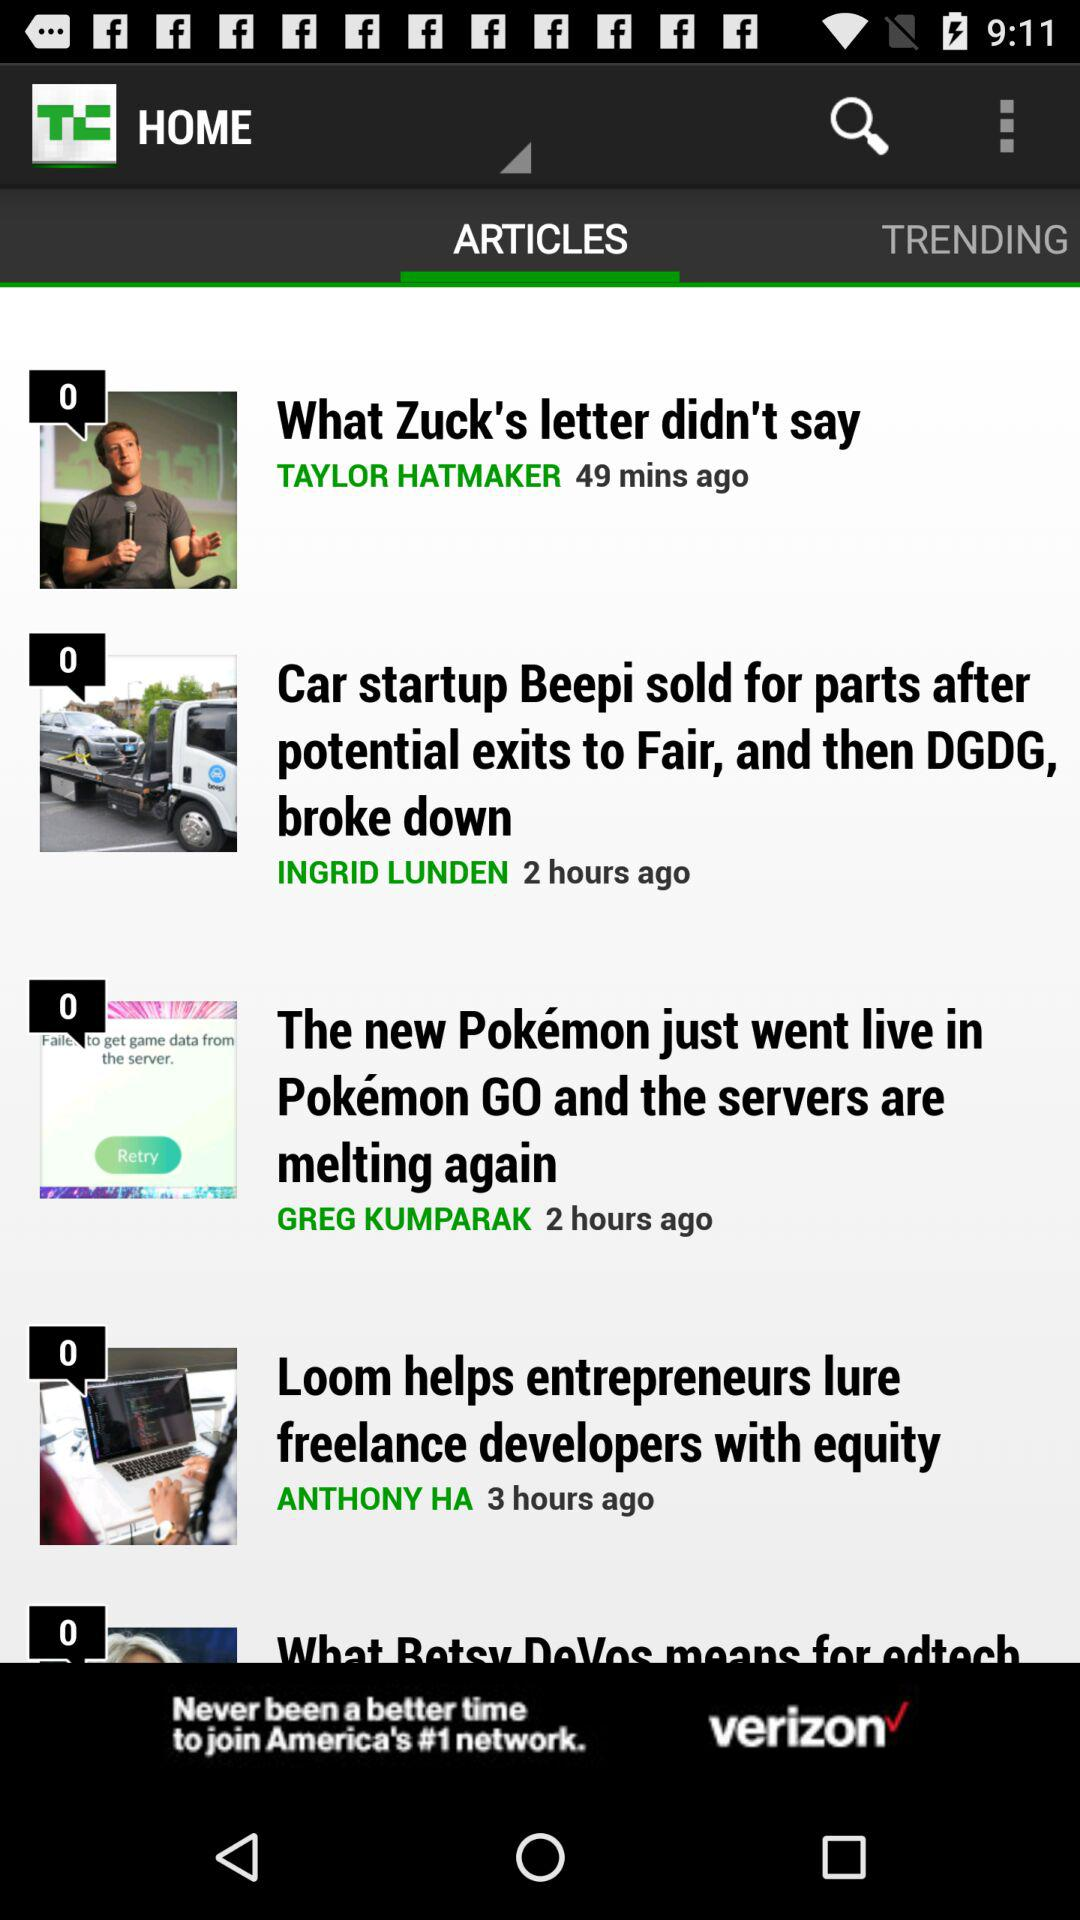Which tab has been selected? The selected tab is "ARTICLES". 